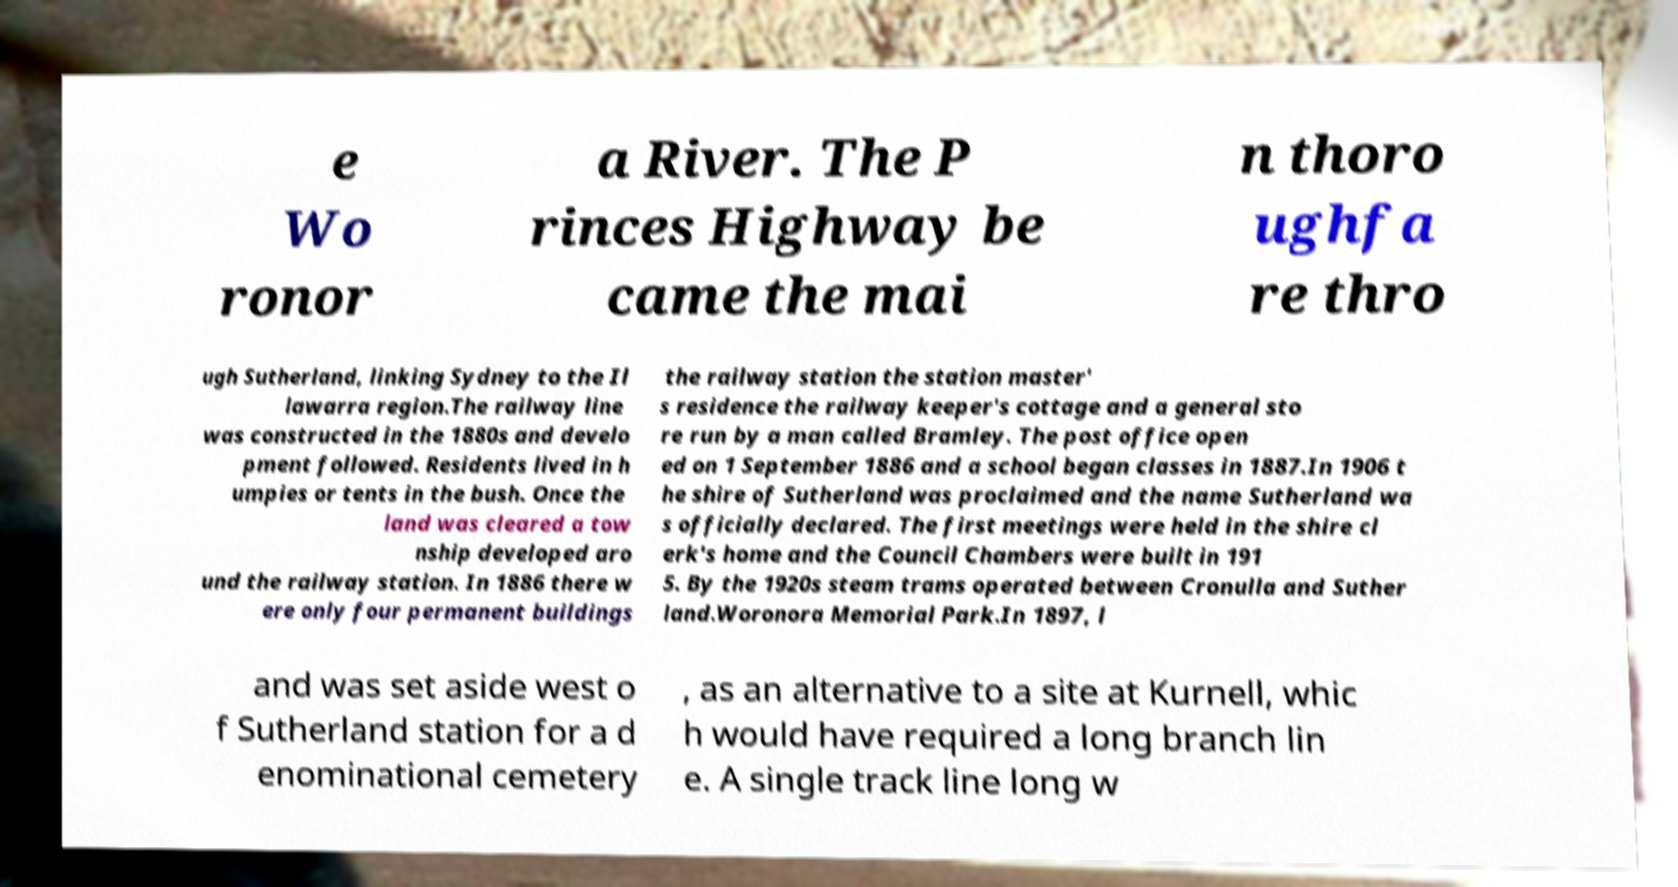Can you read and provide the text displayed in the image?This photo seems to have some interesting text. Can you extract and type it out for me? e Wo ronor a River. The P rinces Highway be came the mai n thoro ughfa re thro ugh Sutherland, linking Sydney to the Il lawarra region.The railway line was constructed in the 1880s and develo pment followed. Residents lived in h umpies or tents in the bush. Once the land was cleared a tow nship developed aro und the railway station. In 1886 there w ere only four permanent buildings the railway station the station master' s residence the railway keeper's cottage and a general sto re run by a man called Bramley. The post office open ed on 1 September 1886 and a school began classes in 1887.In 1906 t he shire of Sutherland was proclaimed and the name Sutherland wa s officially declared. The first meetings were held in the shire cl erk's home and the Council Chambers were built in 191 5. By the 1920s steam trams operated between Cronulla and Suther land.Woronora Memorial Park.In 1897, l and was set aside west o f Sutherland station for a d enominational cemetery , as an alternative to a site at Kurnell, whic h would have required a long branch lin e. A single track line long w 